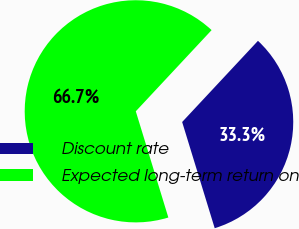<chart> <loc_0><loc_0><loc_500><loc_500><pie_chart><fcel>Discount rate<fcel>Expected long-term return on<nl><fcel>33.31%<fcel>66.69%<nl></chart> 